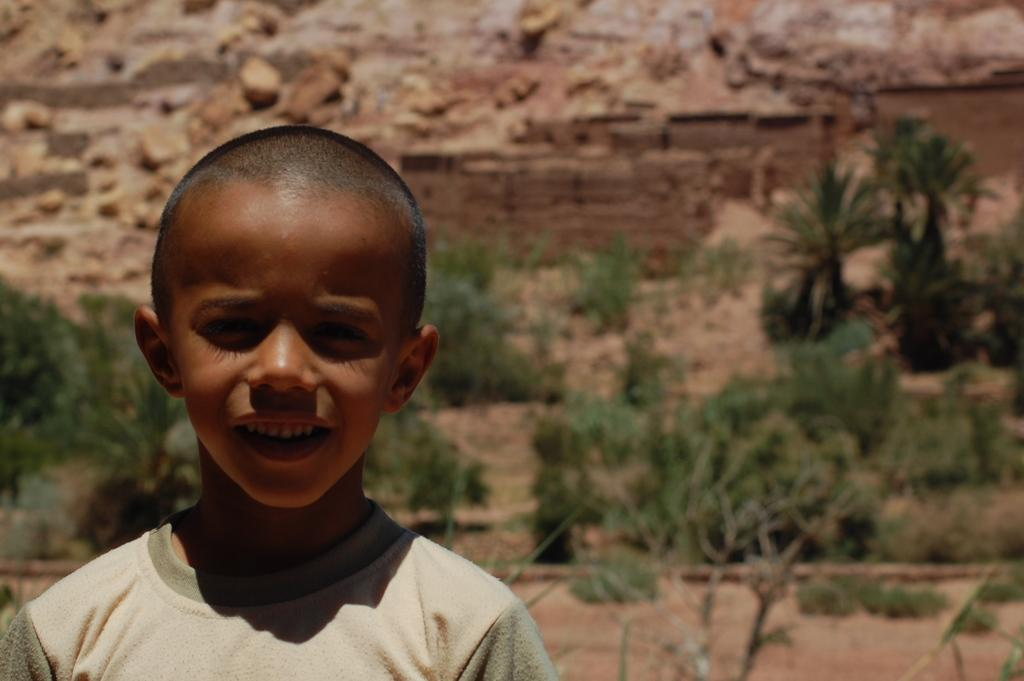What is located on the left side of the image? There is a kid on the left side of the image. What is the expression on the kid's face? The kid is smiling. What type of natural environment is visible in the background of the image? There is grass and soil present in the background of the image. What type of celery is the kid holding in the image? There is no celery present in the image; the kid is not holding any vegetables or objects. How does the balloon support the kid's weight in the image? There is no balloon present in the image, so it cannot be used to support the kid's weight. 